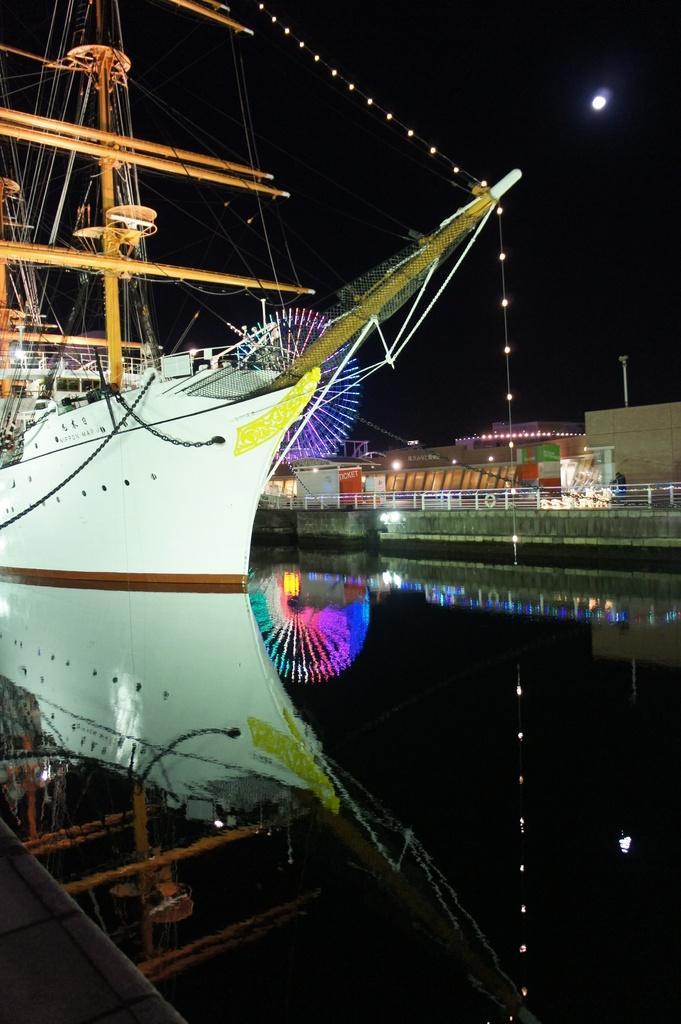Describe this image in one or two sentences. In this picture I can see a ship on the water and I can see buildings, lights in the background and I can see sky. 